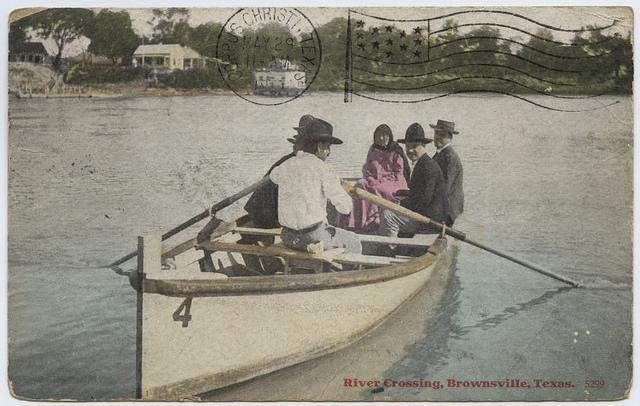How many people are in the photo?
Give a very brief answer. 3. How many elephants have tusks?
Give a very brief answer. 0. 